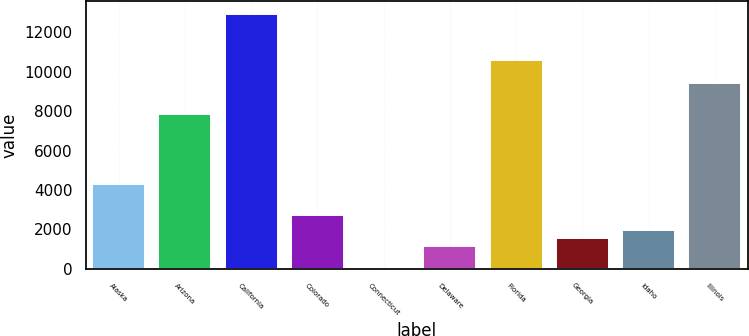<chart> <loc_0><loc_0><loc_500><loc_500><bar_chart><fcel>Alaska<fcel>Arizona<fcel>California<fcel>Colorado<fcel>Connecticut<fcel>Delaware<fcel>Florida<fcel>Georgia<fcel>Idaho<fcel>Illinois<nl><fcel>4315.2<fcel>7845<fcel>12943.6<fcel>2746.4<fcel>1<fcel>1177.6<fcel>10590.4<fcel>1569.8<fcel>1962<fcel>9413.8<nl></chart> 